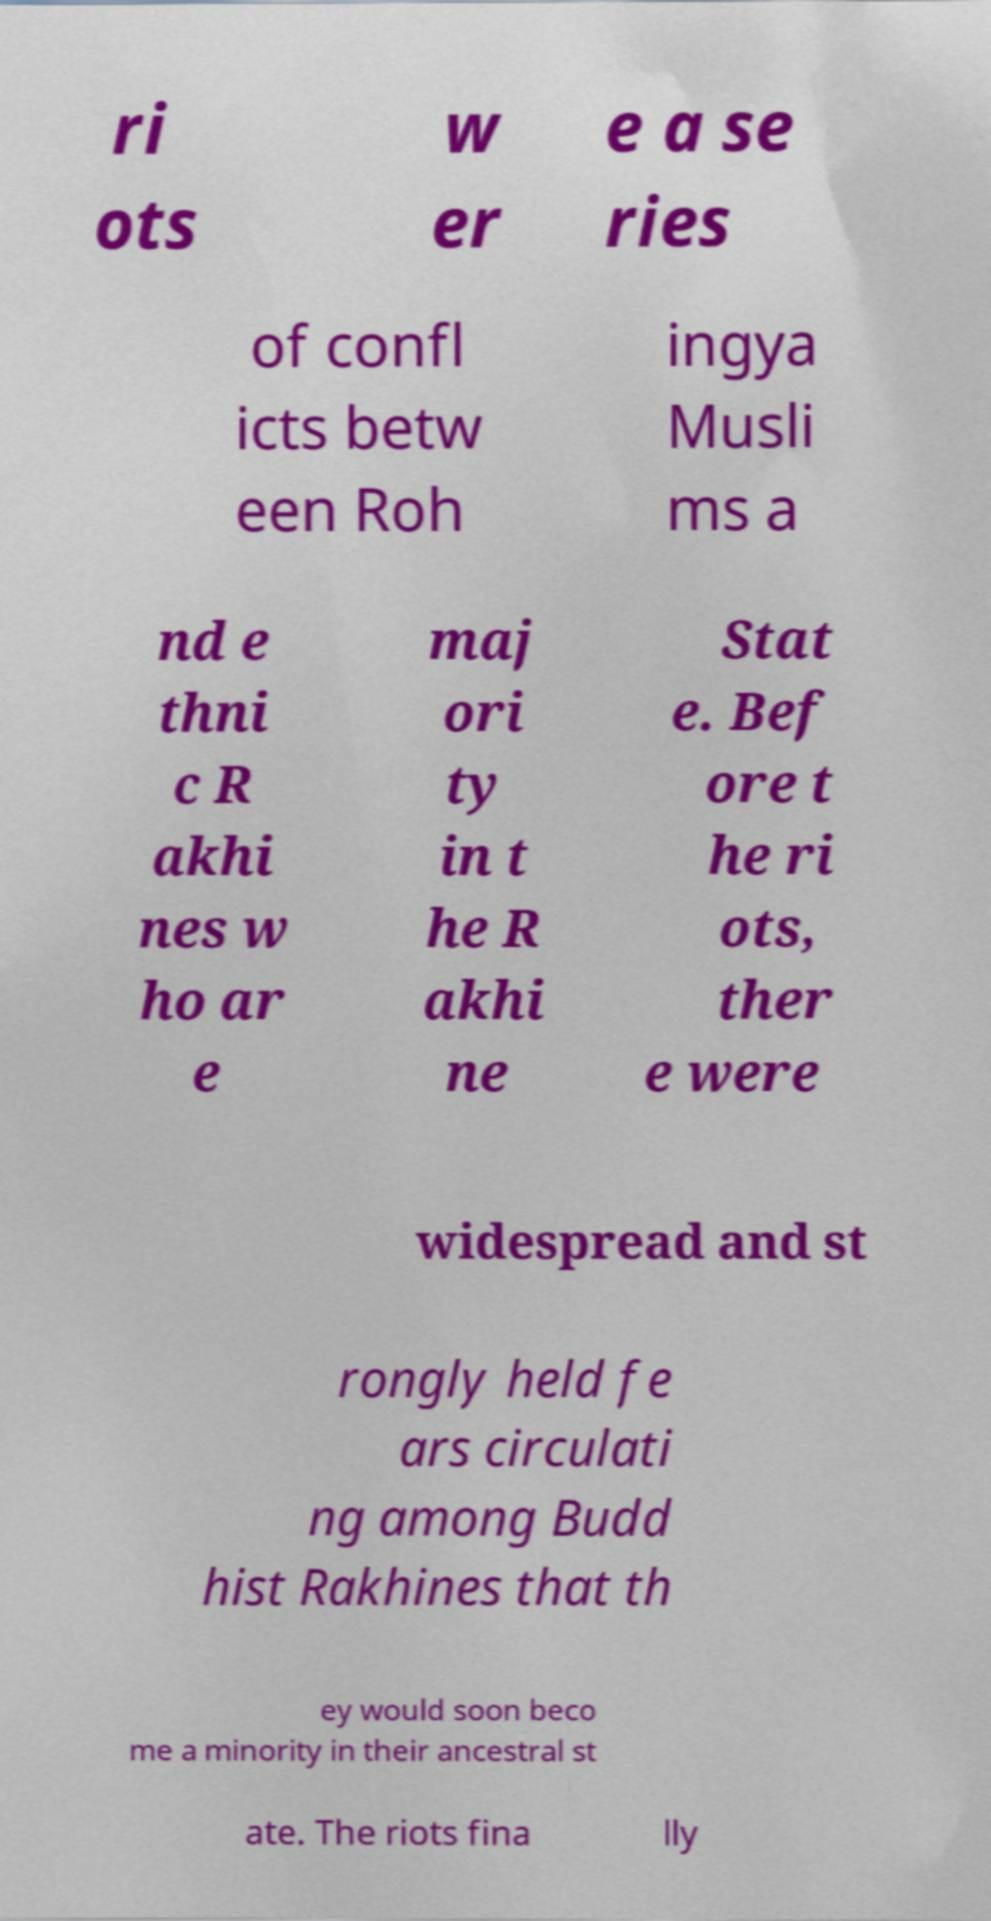Could you assist in decoding the text presented in this image and type it out clearly? ri ots w er e a se ries of confl icts betw een Roh ingya Musli ms a nd e thni c R akhi nes w ho ar e maj ori ty in t he R akhi ne Stat e. Bef ore t he ri ots, ther e were widespread and st rongly held fe ars circulati ng among Budd hist Rakhines that th ey would soon beco me a minority in their ancestral st ate. The riots fina lly 